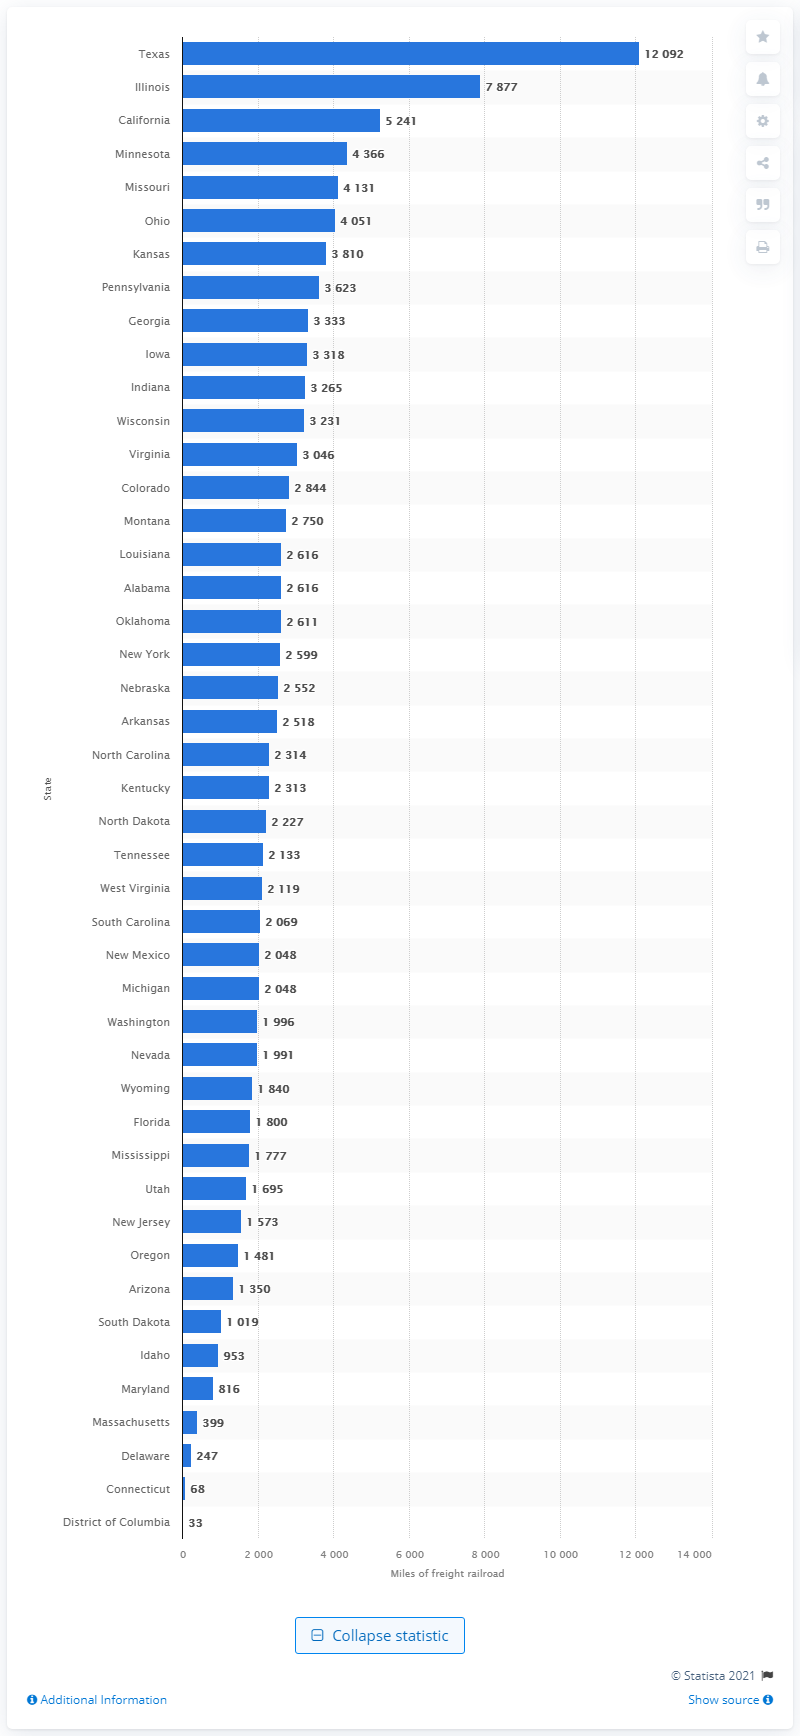Give some essential details in this illustration. In 2015, U.S. Class I railroads operated a total of 2,048 miles of freight railroad in the state of Michigan. 